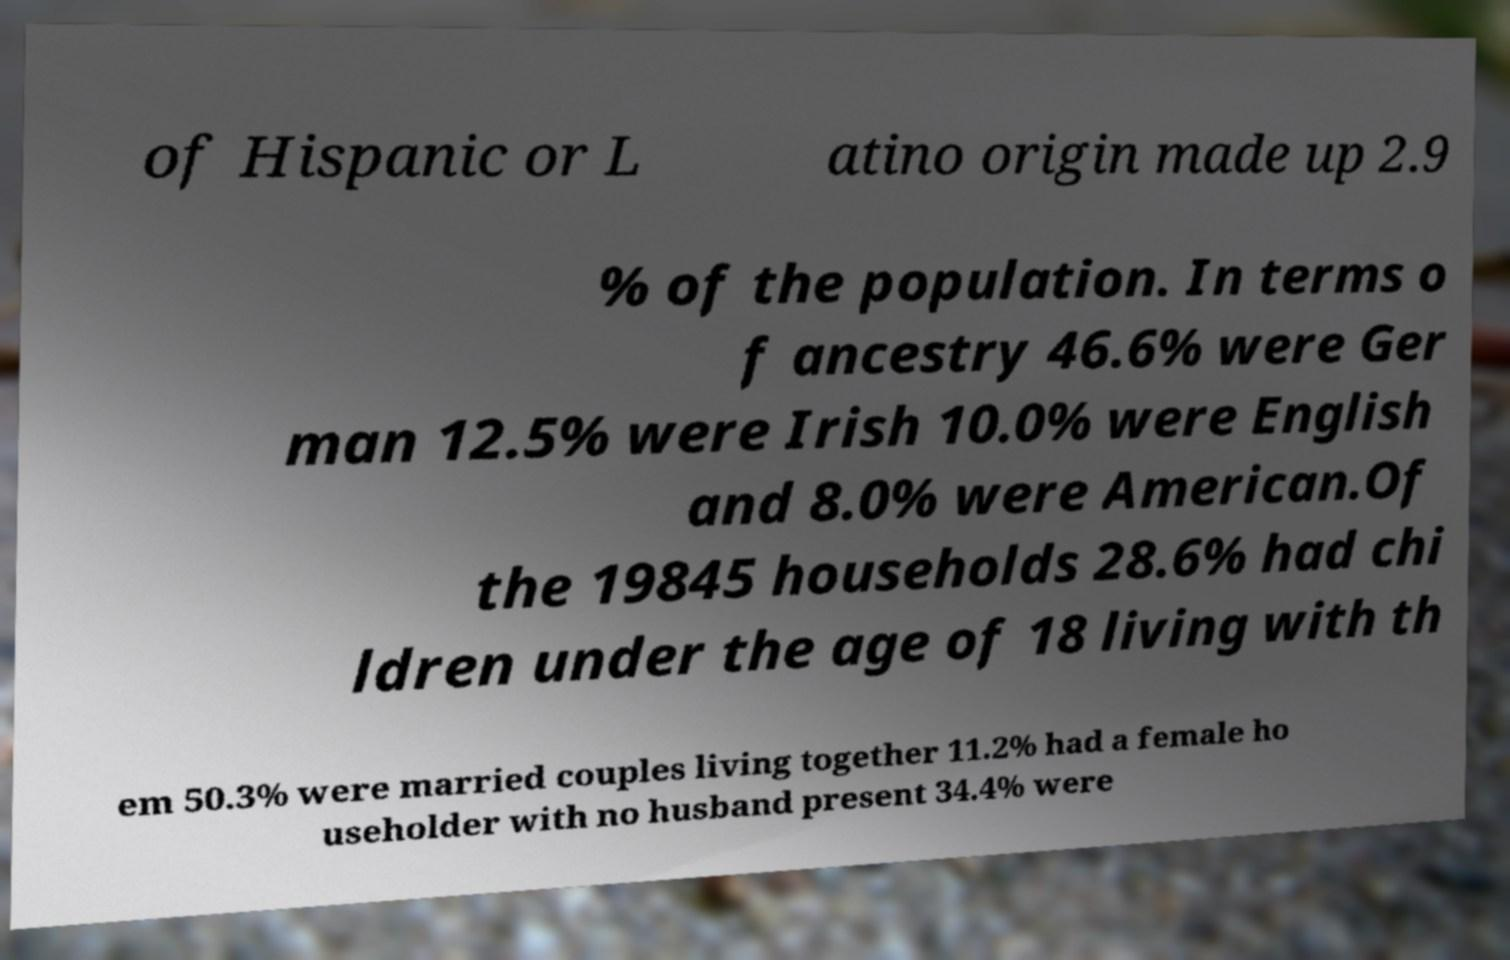Can you accurately transcribe the text from the provided image for me? of Hispanic or L atino origin made up 2.9 % of the population. In terms o f ancestry 46.6% were Ger man 12.5% were Irish 10.0% were English and 8.0% were American.Of the 19845 households 28.6% had chi ldren under the age of 18 living with th em 50.3% were married couples living together 11.2% had a female ho useholder with no husband present 34.4% were 